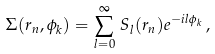Convert formula to latex. <formula><loc_0><loc_0><loc_500><loc_500>\Sigma ( r _ { n } , \phi _ { k } ) = \sum _ { l = 0 } ^ { \infty } \, S _ { l } ( r _ { n } ) e ^ { - i l \phi _ { k } } \, ,</formula> 